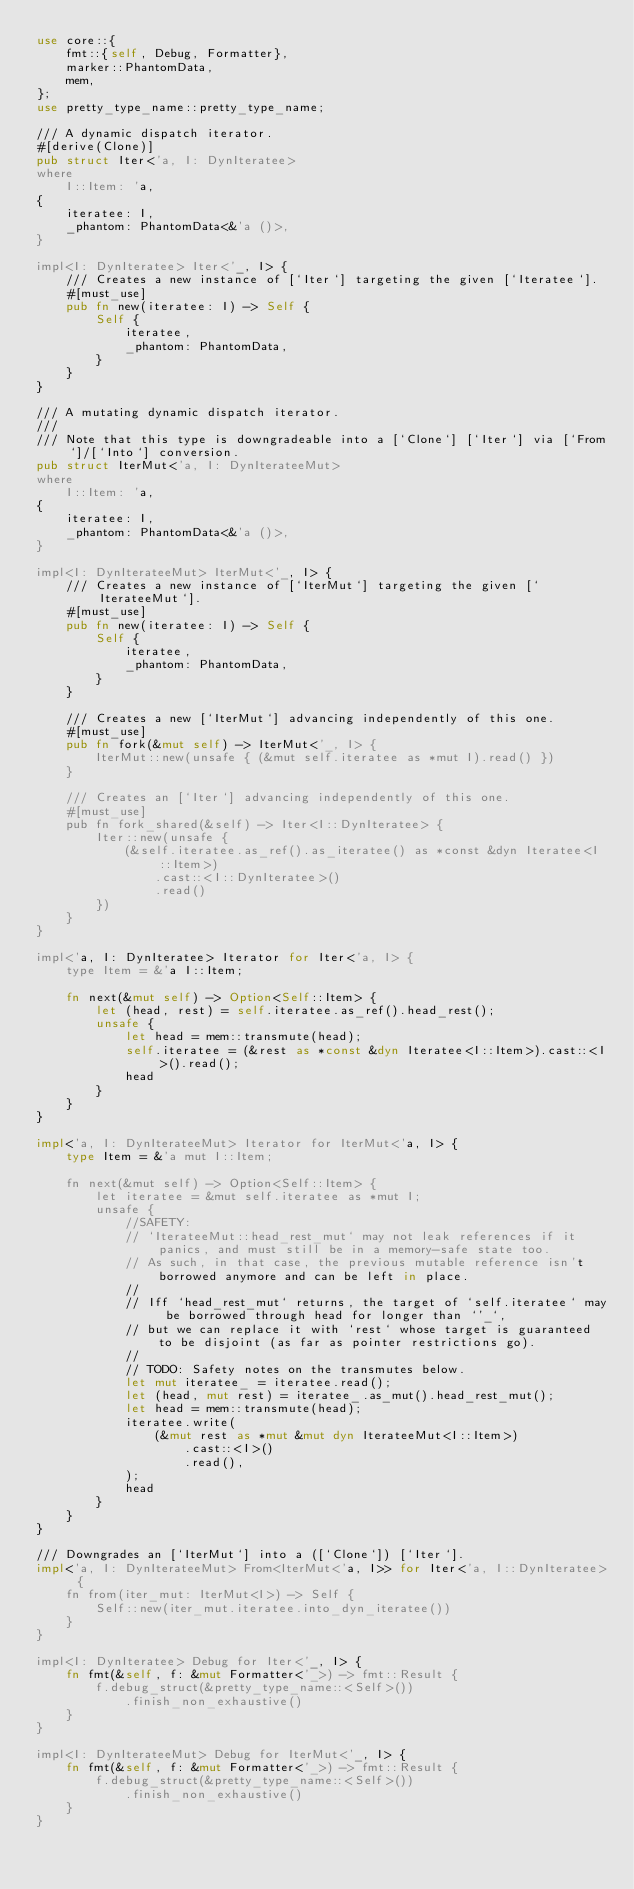<code> <loc_0><loc_0><loc_500><loc_500><_Rust_>use core::{
	fmt::{self, Debug, Formatter},
	marker::PhantomData,
	mem,
};
use pretty_type_name::pretty_type_name;

/// A dynamic dispatch iterator.
#[derive(Clone)]
pub struct Iter<'a, I: DynIteratee>
where
	I::Item: 'a,
{
	iteratee: I,
	_phantom: PhantomData<&'a ()>,
}

impl<I: DynIteratee> Iter<'_, I> {
	/// Creates a new instance of [`Iter`] targeting the given [`Iteratee`].
	#[must_use]
	pub fn new(iteratee: I) -> Self {
		Self {
			iteratee,
			_phantom: PhantomData,
		}
	}
}

/// A mutating dynamic dispatch iterator.
///
/// Note that this type is downgradeable into a [`Clone`] [`Iter`] via [`From`]/[`Into`] conversion.
pub struct IterMut<'a, I: DynIterateeMut>
where
	I::Item: 'a,
{
	iteratee: I,
	_phantom: PhantomData<&'a ()>,
}

impl<I: DynIterateeMut> IterMut<'_, I> {
	/// Creates a new instance of [`IterMut`] targeting the given [`IterateeMut`].
	#[must_use]
	pub fn new(iteratee: I) -> Self {
		Self {
			iteratee,
			_phantom: PhantomData,
		}
	}

	/// Creates a new [`IterMut`] advancing independently of this one.
	#[must_use]
	pub fn fork(&mut self) -> IterMut<'_, I> {
		IterMut::new(unsafe { (&mut self.iteratee as *mut I).read() })
	}

	/// Creates an [`Iter`] advancing independently of this one.
	#[must_use]
	pub fn fork_shared(&self) -> Iter<I::DynIteratee> {
		Iter::new(unsafe {
			(&self.iteratee.as_ref().as_iteratee() as *const &dyn Iteratee<I::Item>)
				.cast::<I::DynIteratee>()
				.read()
		})
	}
}

impl<'a, I: DynIteratee> Iterator for Iter<'a, I> {
	type Item = &'a I::Item;

	fn next(&mut self) -> Option<Self::Item> {
		let (head, rest) = self.iteratee.as_ref().head_rest();
		unsafe {
			let head = mem::transmute(head);
			self.iteratee = (&rest as *const &dyn Iteratee<I::Item>).cast::<I>().read();
			head
		}
	}
}

impl<'a, I: DynIterateeMut> Iterator for IterMut<'a, I> {
	type Item = &'a mut I::Item;

	fn next(&mut self) -> Option<Self::Item> {
		let iteratee = &mut self.iteratee as *mut I;
		unsafe {
			//SAFETY:
			// `IterateeMut::head_rest_mut` may not leak references if it panics, and must still be in a memory-safe state too.
			// As such, in that case, the previous mutable reference isn't borrowed anymore and can be left in place.
			//
			// Iff `head_rest_mut` returns, the target of `self.iteratee` may be borrowed through head for longer than `'_`,
			// but we can replace it with `rest` whose target is guaranteed to be disjoint (as far as pointer restrictions go).
			//
			// TODO: Safety notes on the transmutes below.
			let mut iteratee_ = iteratee.read();
			let (head, mut rest) = iteratee_.as_mut().head_rest_mut();
			let head = mem::transmute(head);
			iteratee.write(
				(&mut rest as *mut &mut dyn IterateeMut<I::Item>)
					.cast::<I>()
					.read(),
			);
			head
		}
	}
}

/// Downgrades an [`IterMut`] into a ([`Clone`]) [`Iter`].
impl<'a, I: DynIterateeMut> From<IterMut<'a, I>> for Iter<'a, I::DynIteratee> {
	fn from(iter_mut: IterMut<I>) -> Self {
		Self::new(iter_mut.iteratee.into_dyn_iteratee())
	}
}

impl<I: DynIteratee> Debug for Iter<'_, I> {
	fn fmt(&self, f: &mut Formatter<'_>) -> fmt::Result {
		f.debug_struct(&pretty_type_name::<Self>())
			.finish_non_exhaustive()
	}
}

impl<I: DynIterateeMut> Debug for IterMut<'_, I> {
	fn fmt(&self, f: &mut Formatter<'_>) -> fmt::Result {
		f.debug_struct(&pretty_type_name::<Self>())
			.finish_non_exhaustive()
	}
}
</code> 